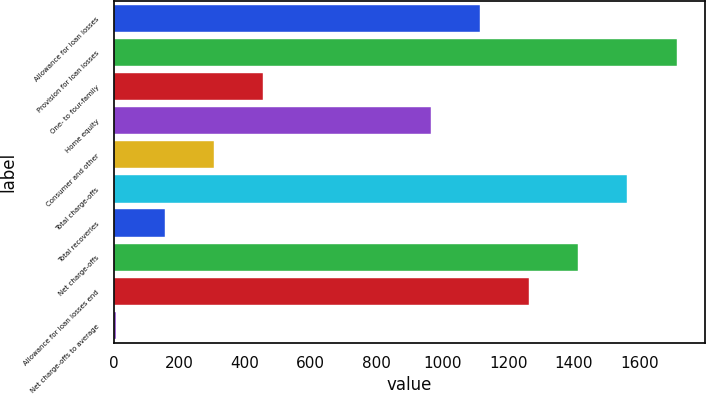<chart> <loc_0><loc_0><loc_500><loc_500><bar_chart><fcel>Allowance for loan losses<fcel>Provision for loan losses<fcel>One- to four-family<fcel>Home equity<fcel>Consumer and other<fcel>Total charge-offs<fcel>Total recoveries<fcel>Net charge-offs<fcel>Allowance for loan losses end<fcel>Net charge-offs to average<nl><fcel>1115.51<fcel>1712.35<fcel>453.67<fcel>966.3<fcel>304.46<fcel>1563.14<fcel>155.25<fcel>1413.93<fcel>1264.72<fcel>6.04<nl></chart> 